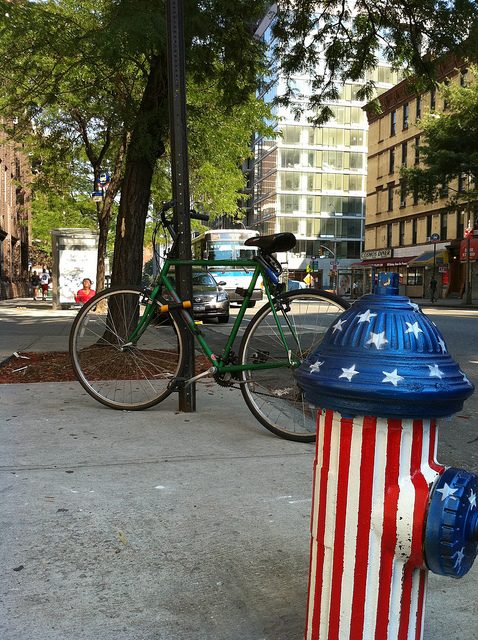<image>Why is the bike connected to the pole? It is unknown why the bike is connected to the pole. It could be for security reasons or to prevent theft. Why is the bike connected to the pole? The bike is connected to the pole to prevent theft and keep it protected. 